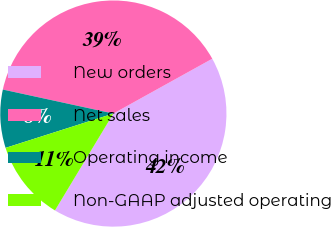Convert chart. <chart><loc_0><loc_0><loc_500><loc_500><pie_chart><fcel>New orders<fcel>Net sales<fcel>Operating income<fcel>Non-GAAP adjusted operating<nl><fcel>41.69%<fcel>38.54%<fcel>8.31%<fcel>11.46%<nl></chart> 